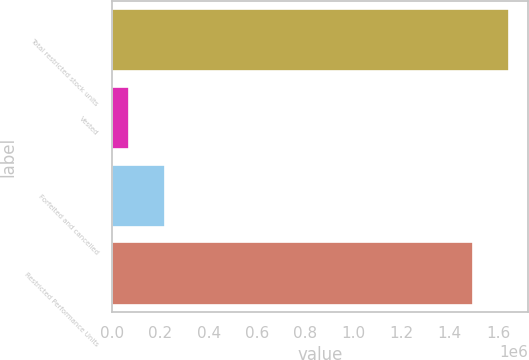Convert chart. <chart><loc_0><loc_0><loc_500><loc_500><bar_chart><fcel>Total restricted stock units<fcel>Vested<fcel>Forfeited and cancelled<fcel>Restricted Performance Units<nl><fcel>1.6439e+06<fcel>69875<fcel>219321<fcel>1.49446e+06<nl></chart> 